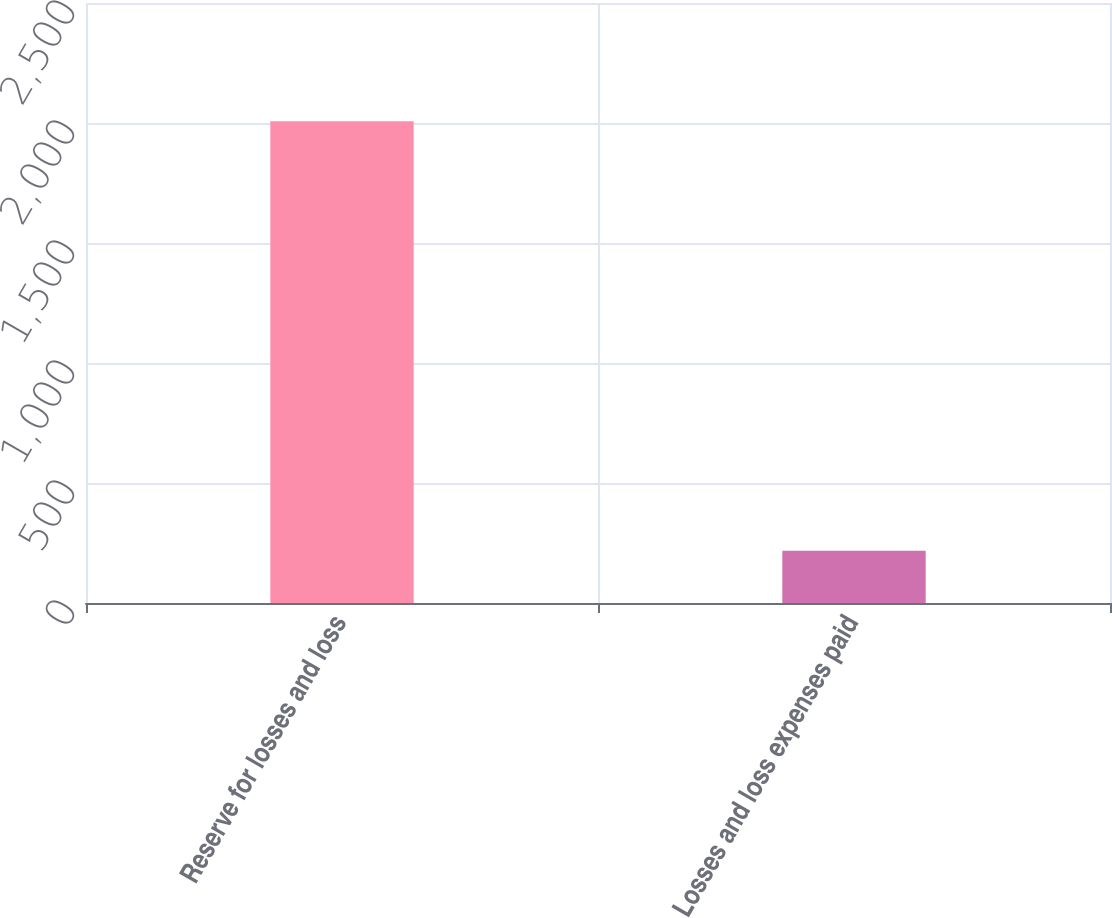Convert chart to OTSL. <chart><loc_0><loc_0><loc_500><loc_500><bar_chart><fcel>Reserve for losses and loss<fcel>Losses and loss expenses paid<nl><fcel>2007.1<fcel>218<nl></chart> 